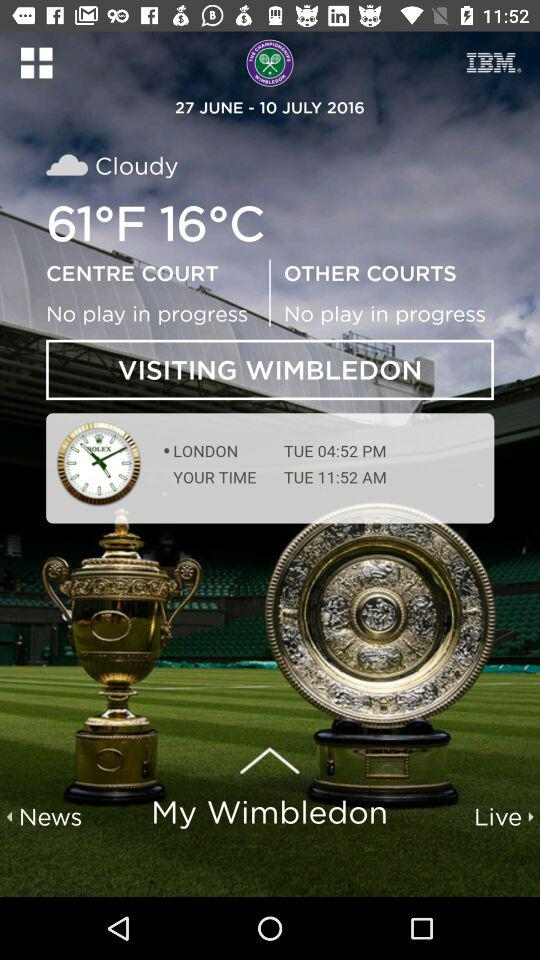What is the temperature? The temperature is 61°F. 